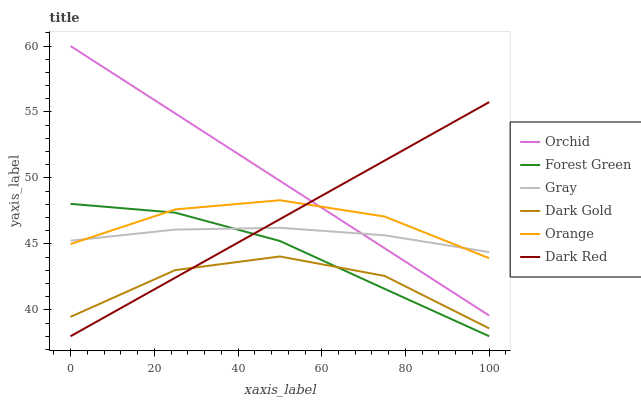Does Dark Red have the minimum area under the curve?
Answer yes or no. No. Does Dark Red have the maximum area under the curve?
Answer yes or no. No. Is Dark Red the smoothest?
Answer yes or no. No. Is Dark Red the roughest?
Answer yes or no. No. Does Dark Gold have the lowest value?
Answer yes or no. No. Does Dark Red have the highest value?
Answer yes or no. No. Is Dark Gold less than Gray?
Answer yes or no. Yes. Is Gray greater than Dark Gold?
Answer yes or no. Yes. Does Dark Gold intersect Gray?
Answer yes or no. No. 